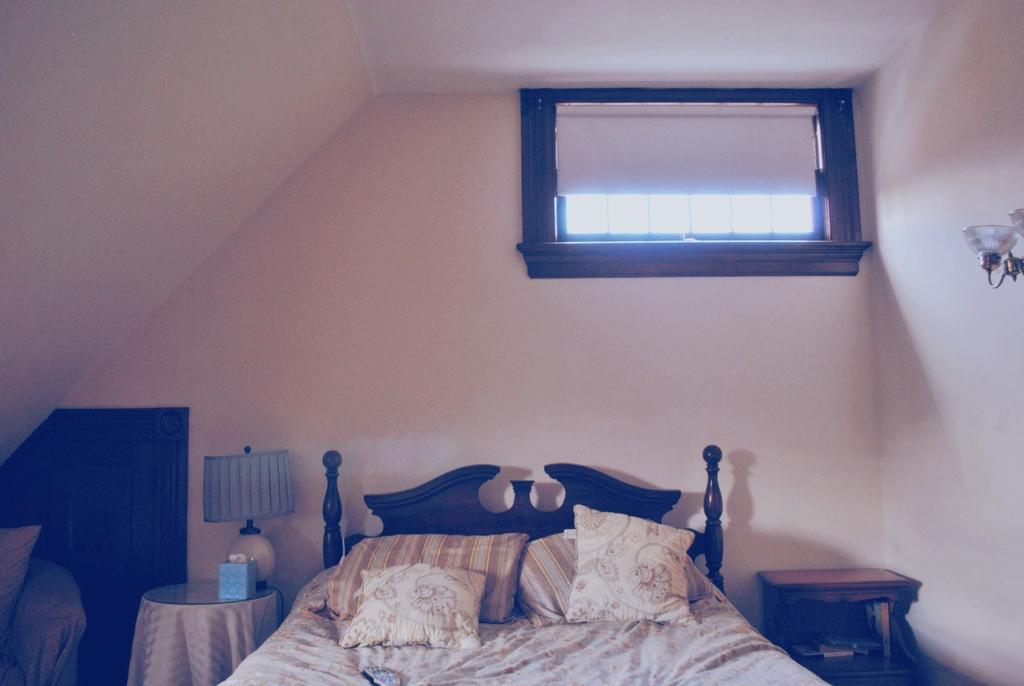What type of opening can be seen in the image? There is a window in the image. What type of structure is present in the image? There is a wall in the image. What provides illumination in the image? There is a light source in the image. What type of furniture is present in the image for sleeping? There is a bed with a bed sheet and pillows in the image. What type of furniture is present in the image for working or studying? There is a desk in the image. What type of furniture is present in the image for placing items? There is a table in the image. What type of lighting is present on the table in the image? There is a bed lamp on the table. What is the name of the stove in the image? There is no stove present in the image. What is the temper of the person using the bed lamp in the image? There is no indication of the person's temper in the image, as it only shows objects and not people. 